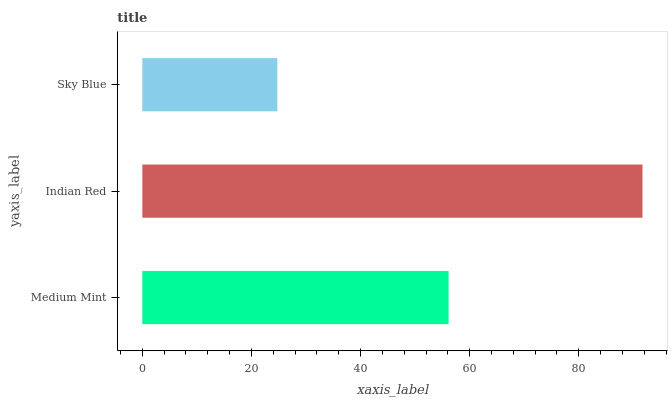Is Sky Blue the minimum?
Answer yes or no. Yes. Is Indian Red the maximum?
Answer yes or no. Yes. Is Indian Red the minimum?
Answer yes or no. No. Is Sky Blue the maximum?
Answer yes or no. No. Is Indian Red greater than Sky Blue?
Answer yes or no. Yes. Is Sky Blue less than Indian Red?
Answer yes or no. Yes. Is Sky Blue greater than Indian Red?
Answer yes or no. No. Is Indian Red less than Sky Blue?
Answer yes or no. No. Is Medium Mint the high median?
Answer yes or no. Yes. Is Medium Mint the low median?
Answer yes or no. Yes. Is Sky Blue the high median?
Answer yes or no. No. Is Indian Red the low median?
Answer yes or no. No. 